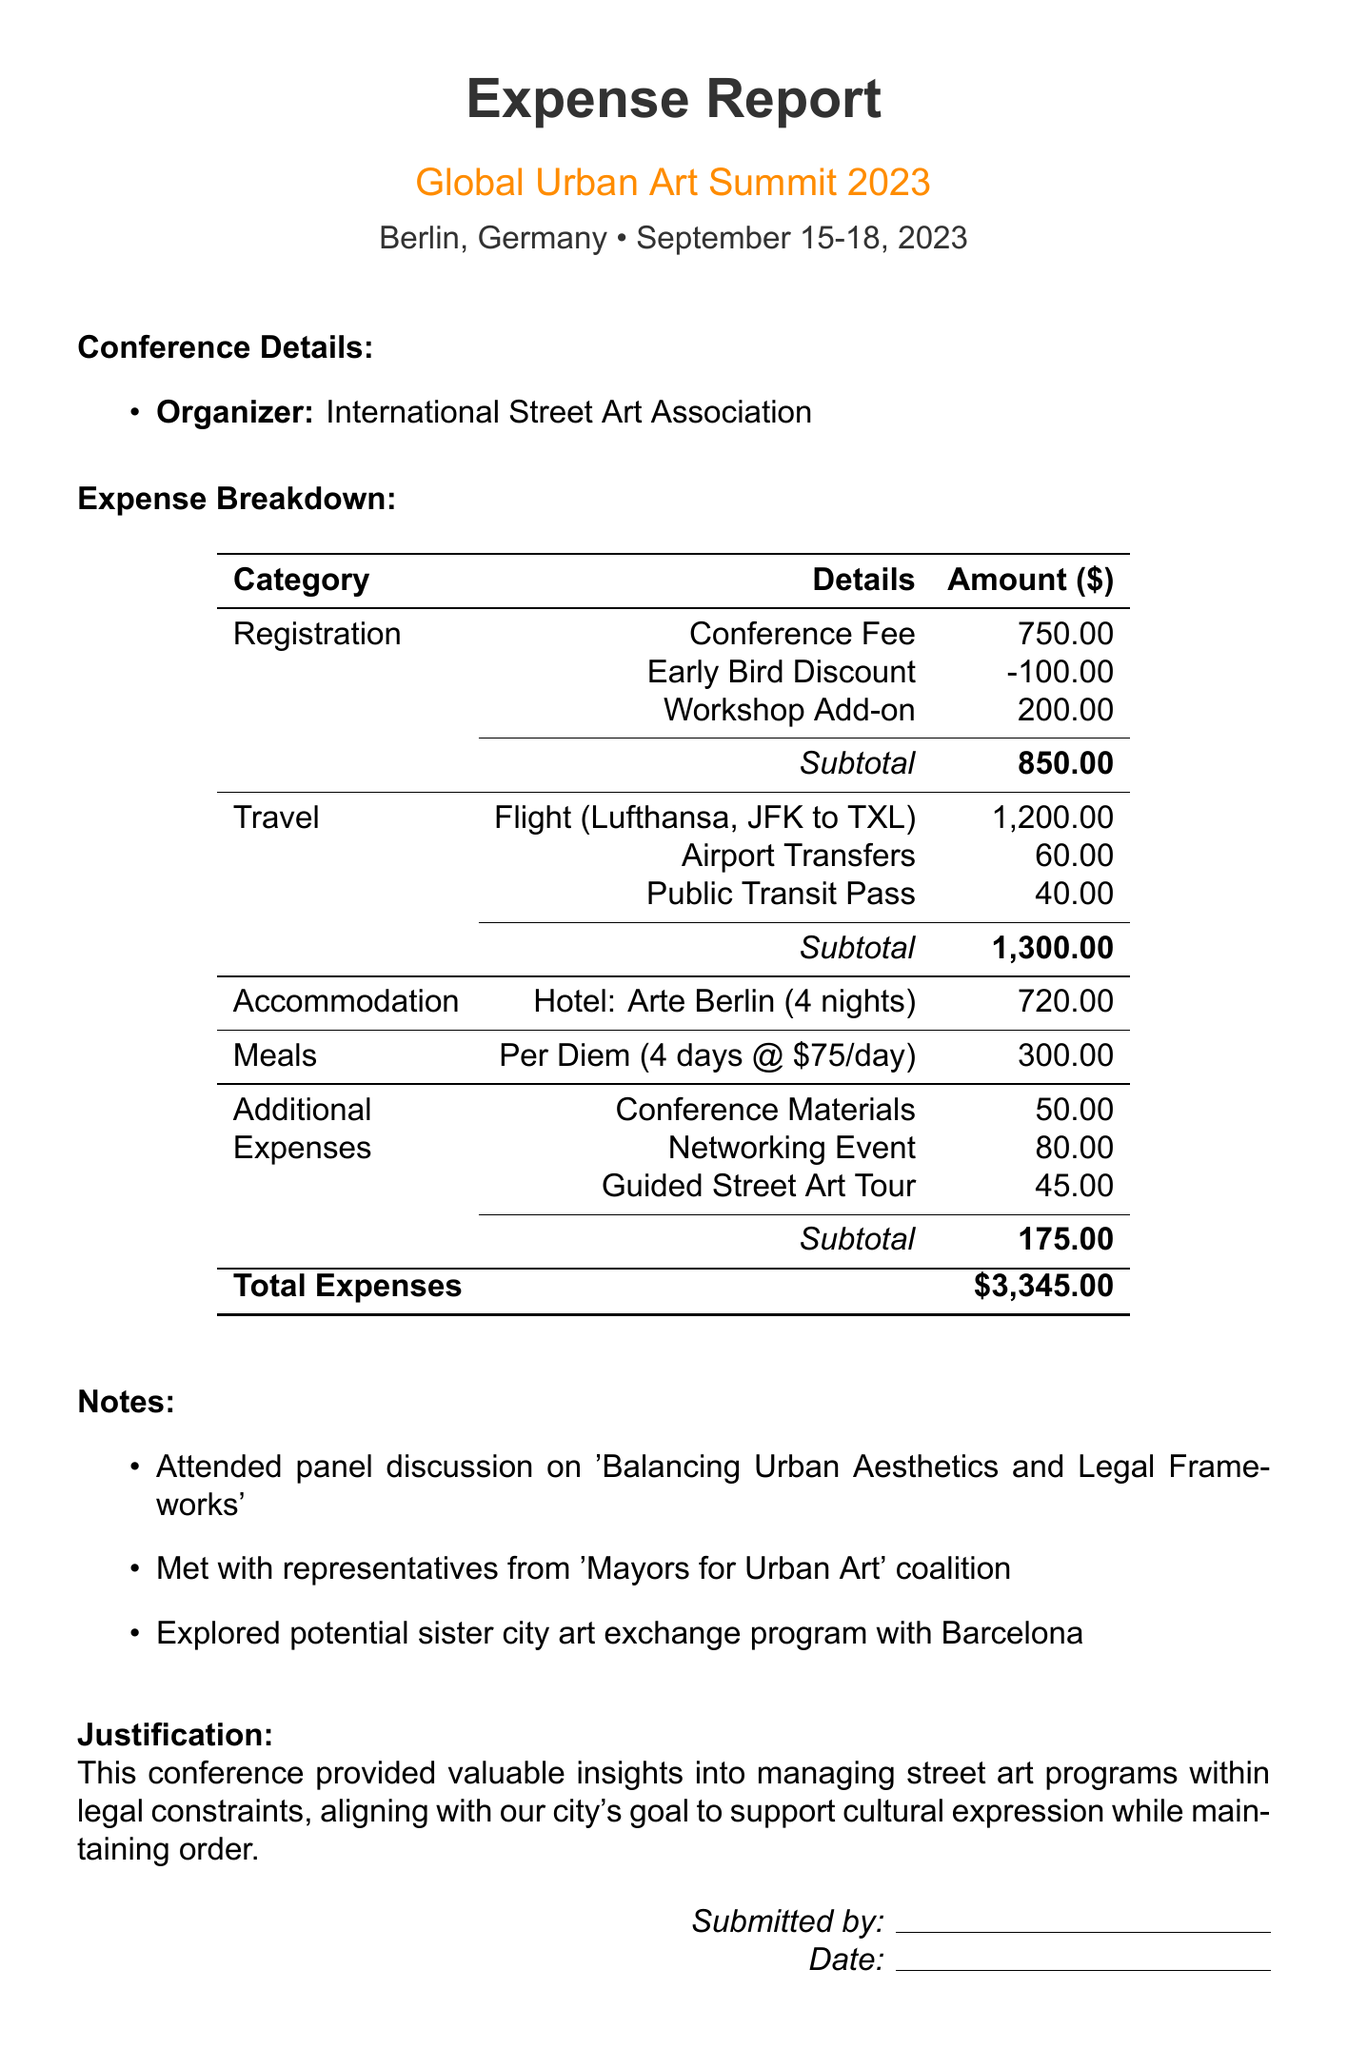What is the total amount of expenses? The total amount of expenses is stated at the end of the document, which adds up all the costs incurred.
Answer: $3,345.00 Who organized the conference? The name of the organization behind the conference is mentioned in the conference details section.
Answer: International Street Art Association What is the cost of the flight? The flight cost is listed under the travel expenses section as a specific individual line item.
Answer: $1,200.00 How many nights was the accommodation booked for? The number of nights stayed in the hotel is detailed in the accommodation section of the document.
Answer: 4 What was the per diem amount for meals? The daily meal allowance is explicitly stated in the meals section of the expense report.
Answer: $75 What is the amount for the guided street art tour? The cost of the guided street art tour is included in the additional expenses section.
Answer: $45 What was the early bird discount for registration? The document specifies the early bird discount applied to the registration fee.
Answer: -$100.00 Which hotel was used for accommodation? The name of the hotel where the accommodation was made is listed in the accommodation details section.
Answer: Arte Berlin 